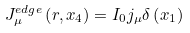<formula> <loc_0><loc_0><loc_500><loc_500>J _ { \mu } ^ { e d g e } \left ( r , x _ { 4 } \right ) = I _ { 0 } j _ { \mu } \delta \left ( x _ { 1 } \right )</formula> 